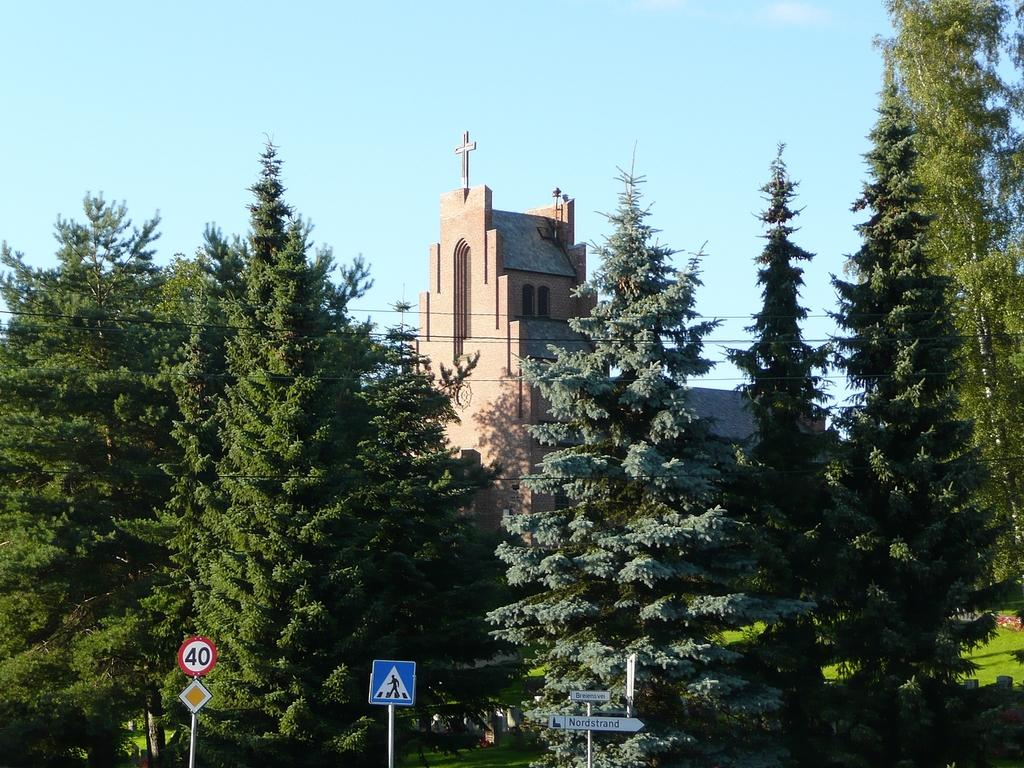What is attached to the poles in the image? There are boards attached to poles in the image. What type of vegetation can be seen in the image? There are green trees in the image. What is covering the ground in the image? There is grass on the ground in the image. What type of structures are visible in the image? There are buildings visible in the image. What is visible in the background of the image? The sky is visible in the background of the image. How does the bun twist in the image? There is no bun present in the image, so it cannot twist. What is the attention span of the trees in the image? Trees do not have an attention span, as they are inanimate objects. 